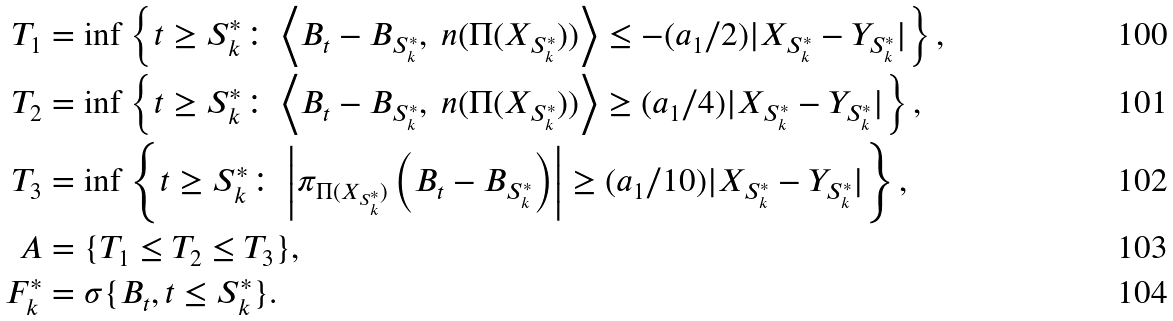Convert formula to latex. <formula><loc_0><loc_0><loc_500><loc_500>T _ { 1 } & = \inf \left \{ t \geq S ^ { * } _ { k } \colon \left < B _ { t } - B _ { S ^ { * } _ { k } } , \ n ( \Pi ( X _ { S ^ { * } _ { k } } ) ) \right > \leq - ( a _ { 1 } / 2 ) | X _ { S ^ { * } _ { k } } - Y _ { S ^ { * } _ { k } } | \right \} , \\ T _ { 2 } & = \inf \left \{ t \geq S ^ { * } _ { k } \colon \left < B _ { t } - B _ { S ^ { * } _ { k } } , \ n ( \Pi ( X _ { S ^ { * } _ { k } } ) ) \right > \geq ( a _ { 1 } / 4 ) | X _ { S ^ { * } _ { k } } - Y _ { S ^ { * } _ { k } } | \right \} , \\ T _ { 3 } & = \inf \left \{ t \geq S ^ { * } _ { k } \colon \left | \pi _ { \Pi ( X _ { S ^ { * } _ { k } } ) } \left ( B _ { t } - B _ { S ^ { * } _ { k } } \right ) \right | \geq ( a _ { 1 } / 1 0 ) | X _ { S ^ { * } _ { k } } - Y _ { S ^ { * } _ { k } } | \right \} , \\ A & = \{ T _ { 1 } \leq T _ { 2 } \leq T _ { 3 } \} , \\ \ F ^ { * } _ { k } & = \sigma \{ B _ { t } , t \leq S ^ { * } _ { k } \} .</formula> 